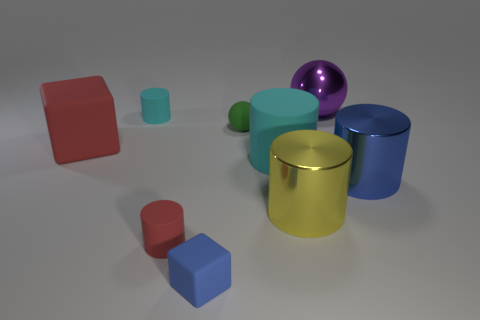Subtract all blue metallic cylinders. How many cylinders are left? 4 Add 1 tiny matte cylinders. How many objects exist? 10 Subtract all purple spheres. How many spheres are left? 1 Subtract all balls. How many objects are left? 7 Subtract 0 purple blocks. How many objects are left? 9 Subtract 4 cylinders. How many cylinders are left? 1 Subtract all gray balls. Subtract all green blocks. How many balls are left? 2 Subtract all gray balls. How many green cylinders are left? 0 Subtract all large metallic things. Subtract all big rubber cubes. How many objects are left? 5 Add 7 small cyan things. How many small cyan things are left? 8 